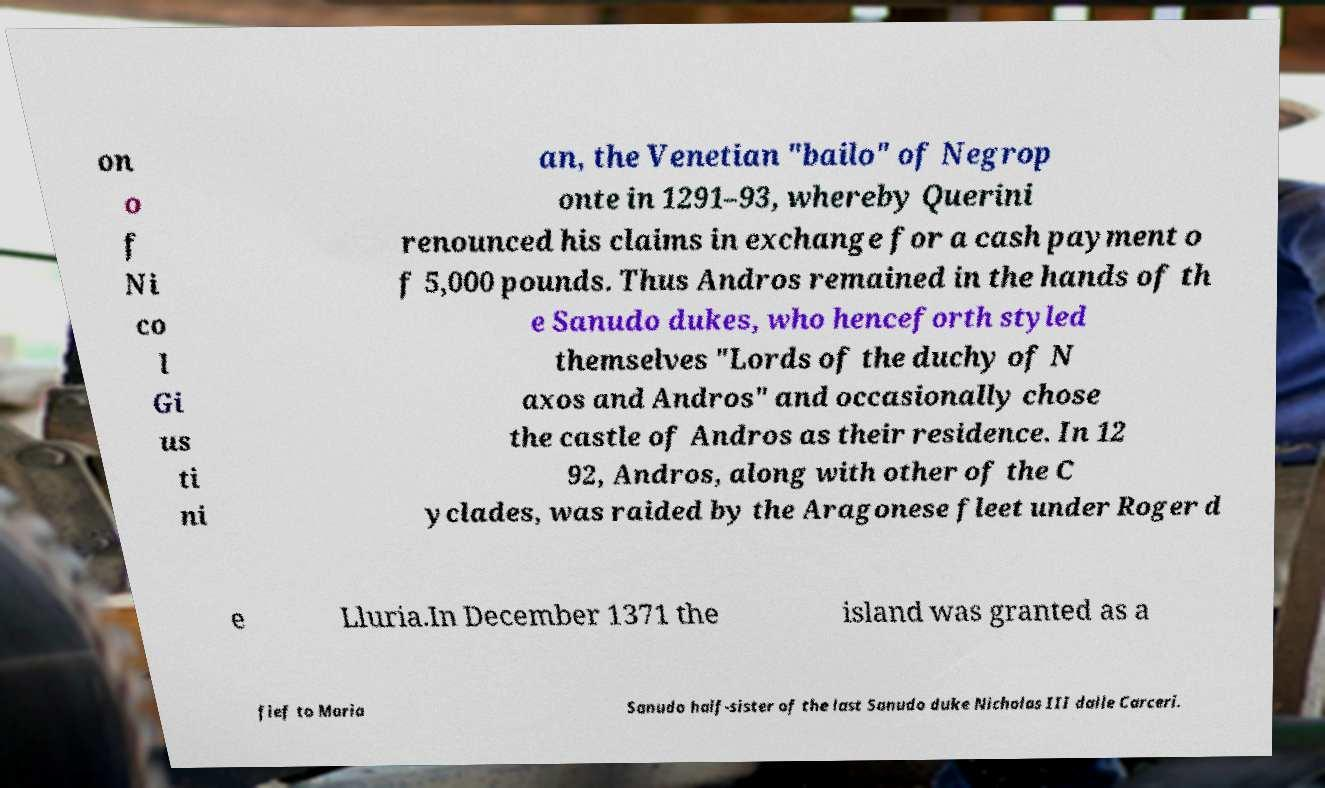Could you extract and type out the text from this image? on o f Ni co l Gi us ti ni an, the Venetian "bailo" of Negrop onte in 1291–93, whereby Querini renounced his claims in exchange for a cash payment o f 5,000 pounds. Thus Andros remained in the hands of th e Sanudo dukes, who henceforth styled themselves "Lords of the duchy of N axos and Andros" and occasionally chose the castle of Andros as their residence. In 12 92, Andros, along with other of the C yclades, was raided by the Aragonese fleet under Roger d e Lluria.In December 1371 the island was granted as a fief to Maria Sanudo half-sister of the last Sanudo duke Nicholas III dalle Carceri. 